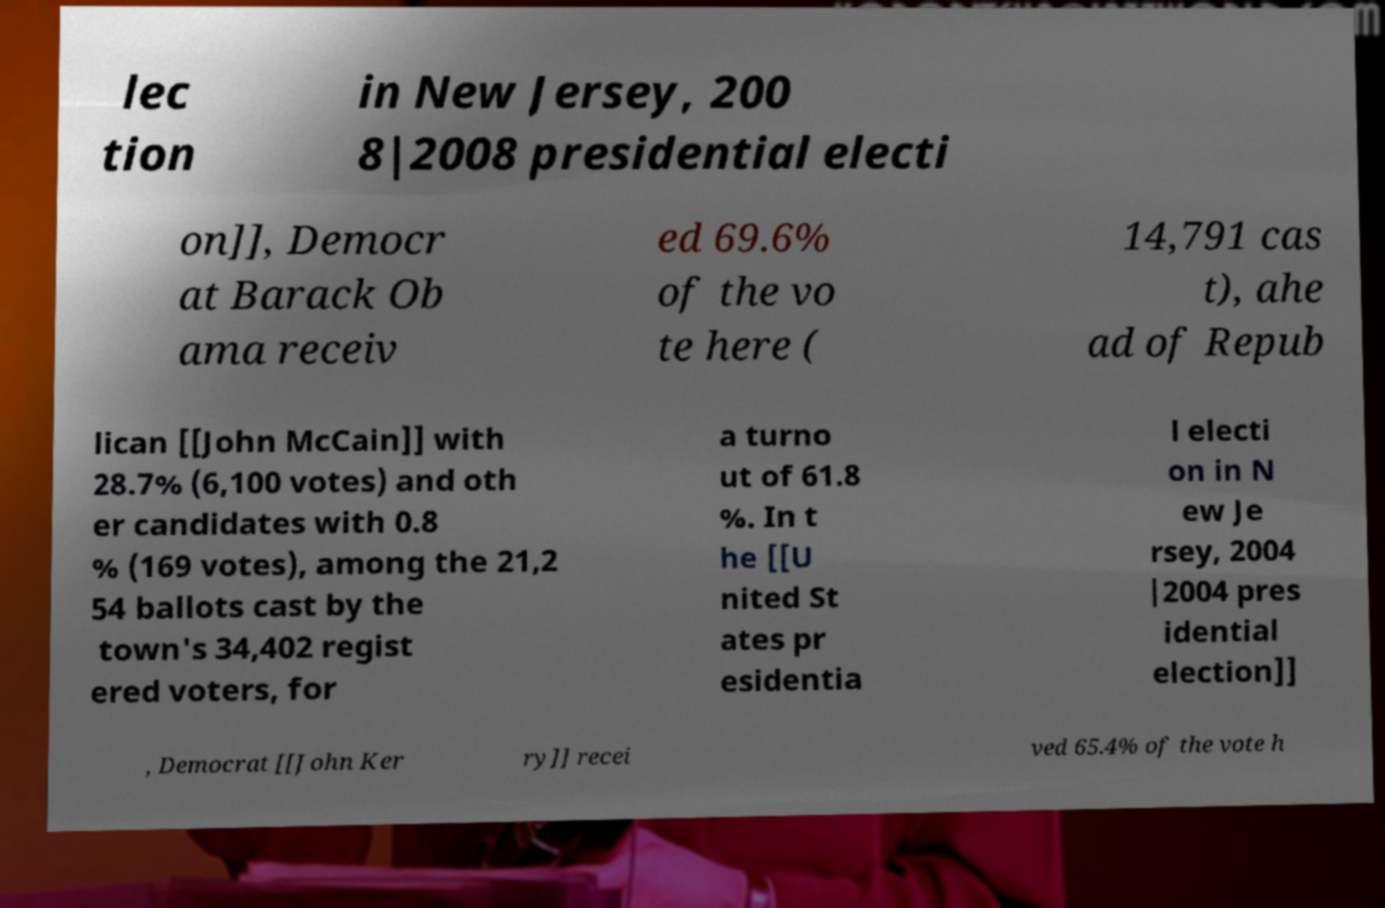Could you assist in decoding the text presented in this image and type it out clearly? lec tion in New Jersey, 200 8|2008 presidential electi on]], Democr at Barack Ob ama receiv ed 69.6% of the vo te here ( 14,791 cas t), ahe ad of Repub lican [[John McCain]] with 28.7% (6,100 votes) and oth er candidates with 0.8 % (169 votes), among the 21,2 54 ballots cast by the town's 34,402 regist ered voters, for a turno ut of 61.8 %. In t he [[U nited St ates pr esidentia l electi on in N ew Je rsey, 2004 |2004 pres idential election]] , Democrat [[John Ker ry]] recei ved 65.4% of the vote h 